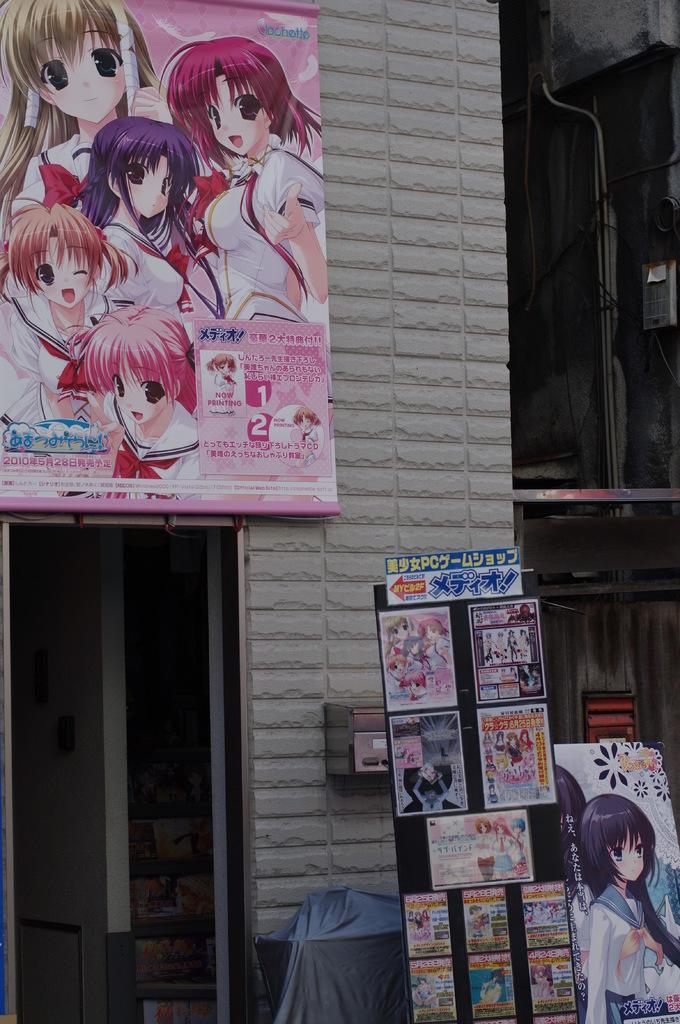Describe this image in one or two sentences. In this image, we can see hoardings and in the background, there is building. 